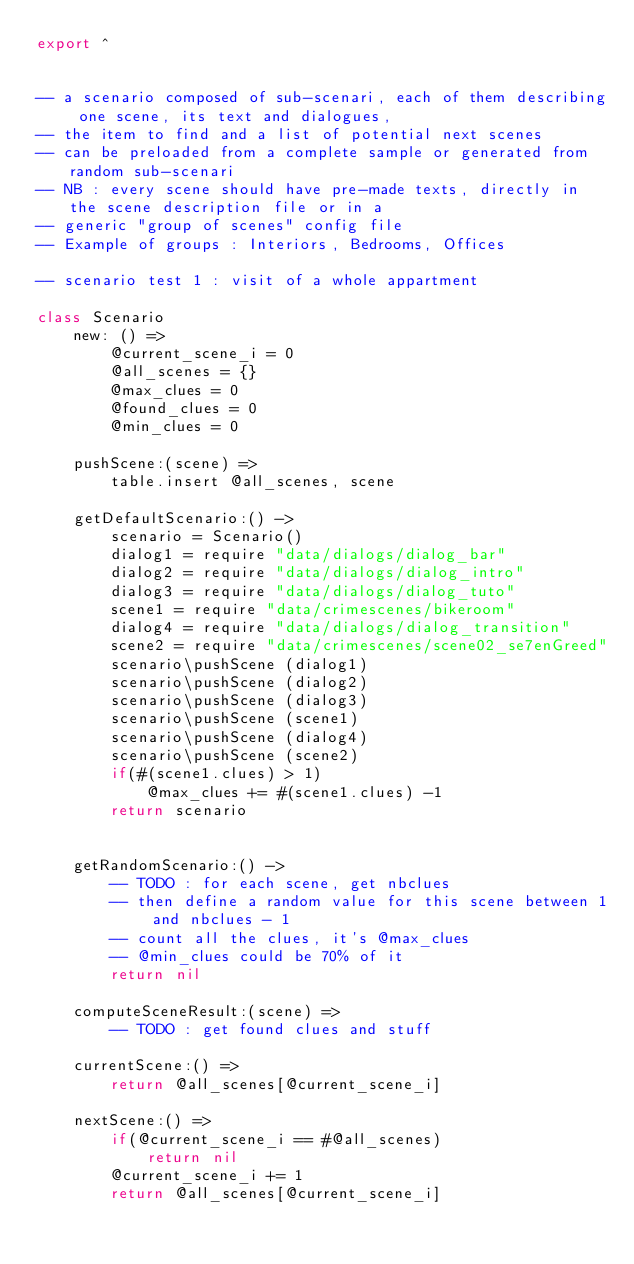Convert code to text. <code><loc_0><loc_0><loc_500><loc_500><_MoonScript_>export ^


-- a scenario composed of sub-scenari, each of them describing one scene, its text and dialogues,
-- the item to find and a list of potential next scenes
-- can be preloaded from a complete sample or generated from random sub-scenari
-- NB : every scene should have pre-made texts, directly in the scene description file or in a
-- generic "group of scenes" config file
-- Example of groups : Interiors, Bedrooms, Offices

-- scenario test 1 : visit of a whole appartment

class Scenario
    new: () =>
        @current_scene_i = 0
        @all_scenes = {}
        @max_clues = 0
        @found_clues = 0
        @min_clues = 0

    pushScene:(scene) =>
        table.insert @all_scenes, scene

    getDefaultScenario:() ->
        scenario = Scenario()
        dialog1 = require "data/dialogs/dialog_bar"
        dialog2 = require "data/dialogs/dialog_intro"
        dialog3 = require "data/dialogs/dialog_tuto"
        scene1 = require "data/crimescenes/bikeroom"
        dialog4 = require "data/dialogs/dialog_transition"
        scene2 = require "data/crimescenes/scene02_se7enGreed"
        scenario\pushScene (dialog1)
        scenario\pushScene (dialog2)
        scenario\pushScene (dialog3)
        scenario\pushScene (scene1)
        scenario\pushScene (dialog4)
        scenario\pushScene (scene2)
        if(#(scene1.clues) > 1)
            @max_clues += #(scene1.clues) -1
        return scenario


    getRandomScenario:() ->
        -- TODO : for each scene, get nbclues
        -- then define a random value for this scene between 1 and nbclues - 1
        -- count all the clues, it's @max_clues
        -- @min_clues could be 70% of it
        return nil

    computeSceneResult:(scene) =>
        -- TODO : get found clues and stuff

    currentScene:() =>
        return @all_scenes[@current_scene_i]

    nextScene:() =>
        if(@current_scene_i == #@all_scenes)
            return nil
        @current_scene_i += 1
        return @all_scenes[@current_scene_i]


</code> 